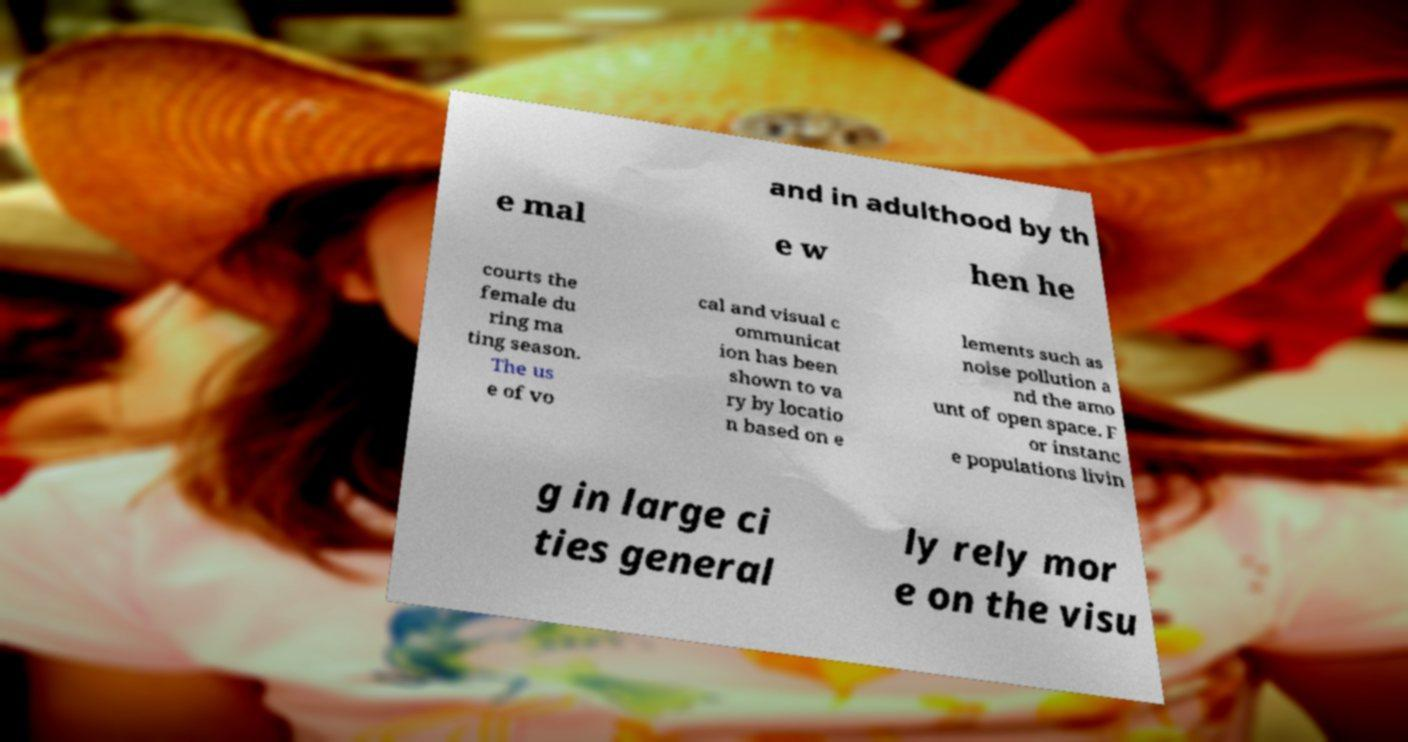I need the written content from this picture converted into text. Can you do that? and in adulthood by th e mal e w hen he courts the female du ring ma ting season. The us e of vo cal and visual c ommunicat ion has been shown to va ry by locatio n based on e lements such as noise pollution a nd the amo unt of open space. F or instanc e populations livin g in large ci ties general ly rely mor e on the visu 